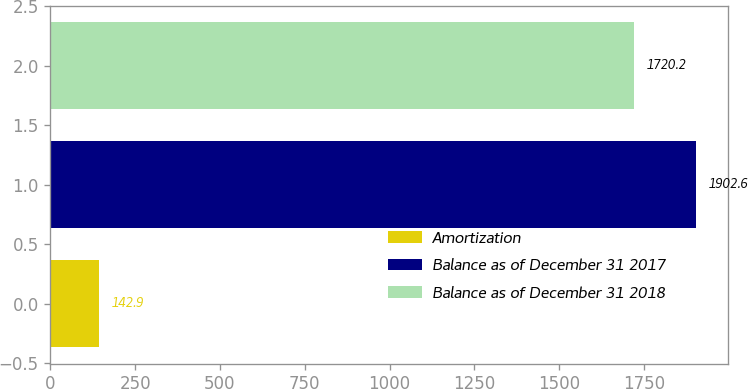Convert chart. <chart><loc_0><loc_0><loc_500><loc_500><bar_chart><fcel>Amortization<fcel>Balance as of December 31 2017<fcel>Balance as of December 31 2018<nl><fcel>142.9<fcel>1902.6<fcel>1720.2<nl></chart> 